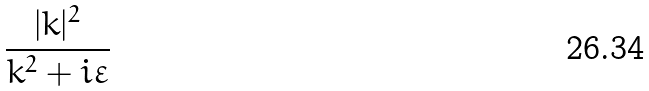Convert formula to latex. <formula><loc_0><loc_0><loc_500><loc_500>\frac { | k | ^ { 2 } } { k ^ { 2 } + i \varepsilon }</formula> 